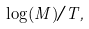Convert formula to latex. <formula><loc_0><loc_0><loc_500><loc_500>\log ( M ) / T ,</formula> 